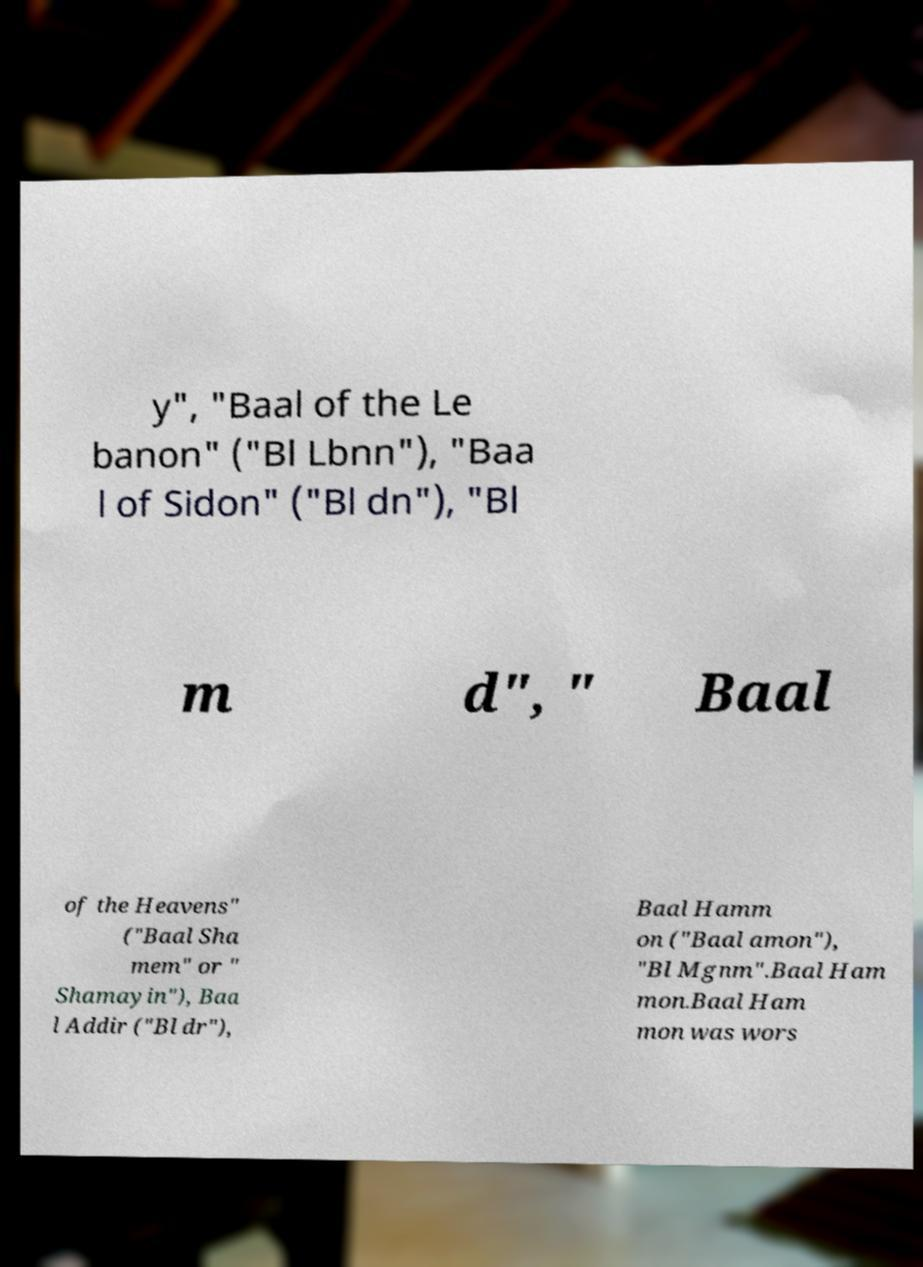I need the written content from this picture converted into text. Can you do that? y", "Baal of the Le banon" ("Bl Lbnn"), "Baa l of Sidon" ("Bl dn"), "Bl m d", " Baal of the Heavens" ("Baal Sha mem" or " Shamayin"), Baa l Addir ("Bl dr"), Baal Hamm on ("Baal amon"), "Bl Mgnm".Baal Ham mon.Baal Ham mon was wors 